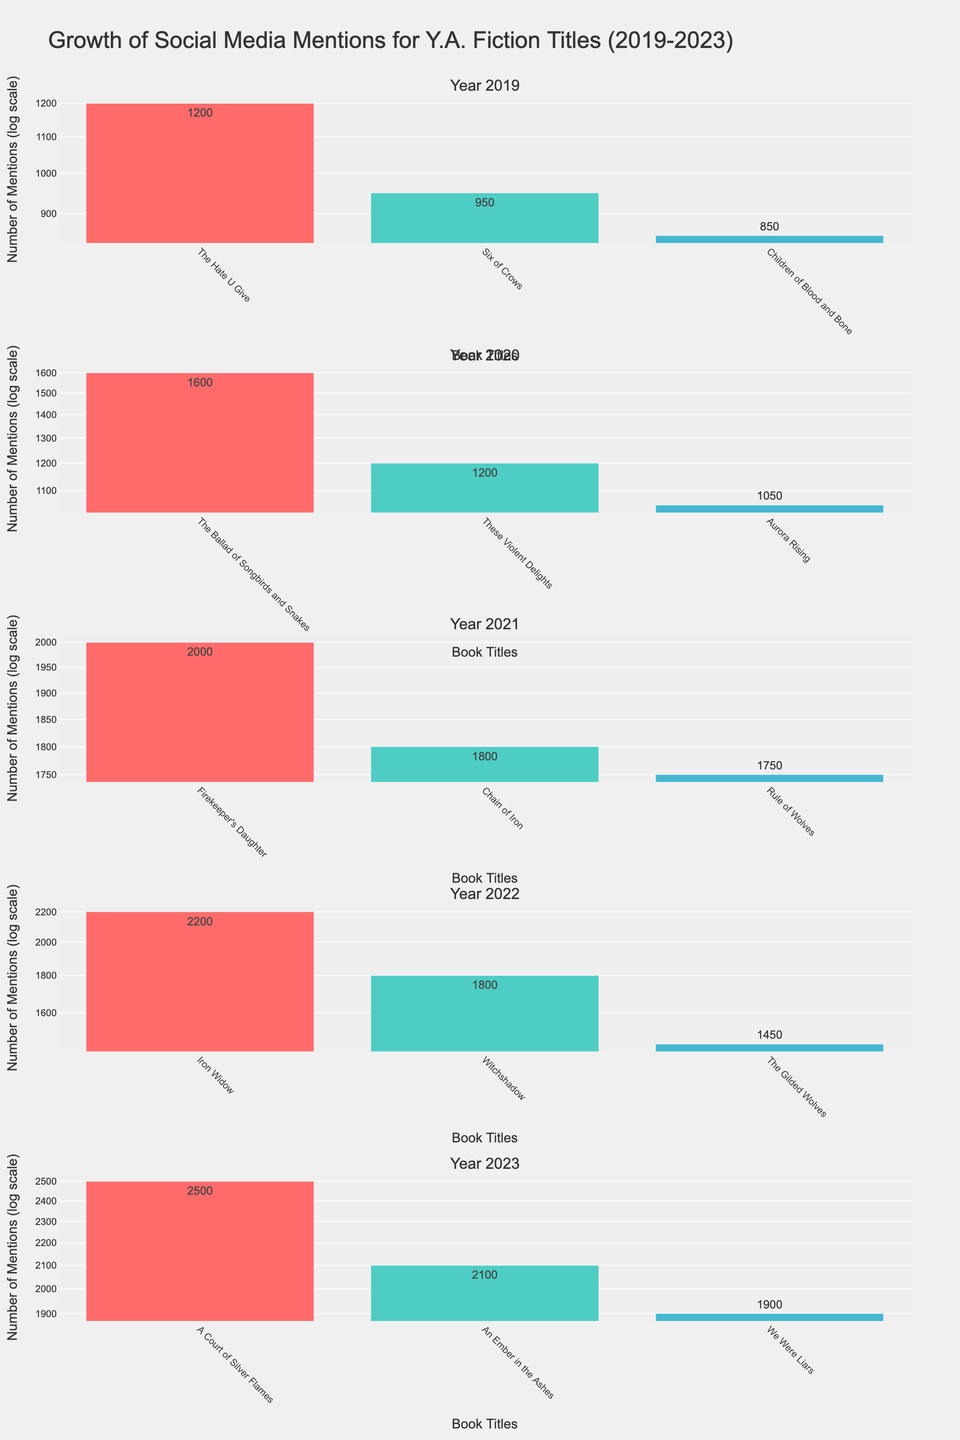what is the title of the plot? The title of the plot is displayed at the top of the figure. It reads "Growth of Social Media Mentions for Y.A. Fiction Titles (2019-2023)".
Answer: Growth of Social Media Mentions for Y.A. Fiction Titles (2019-2023) how many books are represented in the year 2021? Look at the subplot labeled "Year 2021". Count the number of bars present in this subplot, which represent the books. There are three bars.
Answer: 3 which year shows the highest growth in social media mentions for a single book? Examine the height of the bars across all subplots, considering the log scale. The book with the highest mentions appears in the subplot for 2023 with "A Court of Silver Flames" reaching 2500 mentions.
Answer: 2023 which book has the fewest social media mentions in 2020? Look at the subplot labeled "Year 2020" and determine the book with the shortest bar, "Aurora Rising" with 1050 mentions.
Answer: Aurora Rising among the books listed in 2022, which one had the second highest mentions? In the subplot for the year 2022, "Witchshadow" has the second highest number of social media mentions after "Iron Widow".
Answer: Witchshadow what is the difference in mentions between the highest mentioned book in 2019 and the highest mentioned book in 2021? "The Hate U Give" in 2019 had 1200 mentions and "Firekeeper's Daughter" in 2021 had 2000 mentions. The difference is 2000 - 1200.
Answer: 800 which book has the closest number of mentions to "Chain of Iron" in 2021 but in any other year? "Chain of Iron" in 2021 has 1800 mentions. "Witchshadow" in 2022 has a close number of 1800 mentions.
Answer: Witchshadow what is the average number of mentions of books in 2023? Sum the mentions for 2023: 2500 ("A Court of Silver Flames") + 1900 ("We Were Liars") + 2100 ("An Ember in the Ashes"). Then divide by 3.
Answer: 2167 